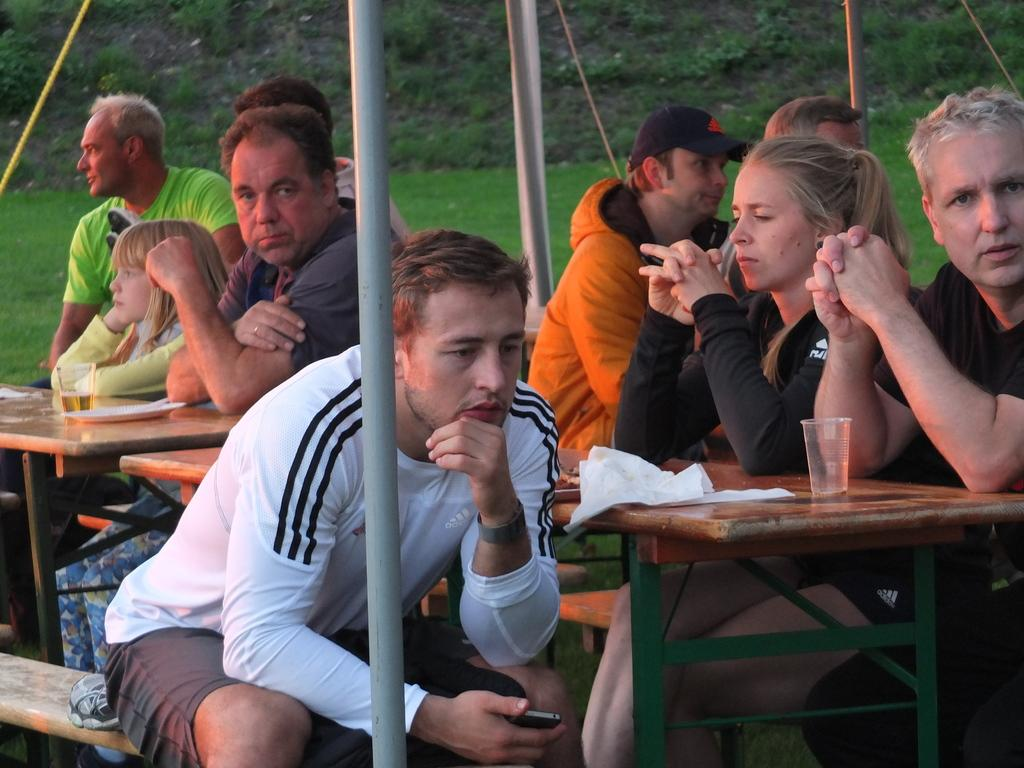What are the people in the image doing? The people in the image are seated. What are the people seated on? The people are seated on chairs. What can be seen on the table in the image? There are glasses and plates on the table. What type of material is visible in the image? There are metal rods visible in the image. What type of natural environment is present in the image? There is grass in the image. How does the toothbrush support the people in the image? There is no toothbrush present in the image, so it cannot support the people. 